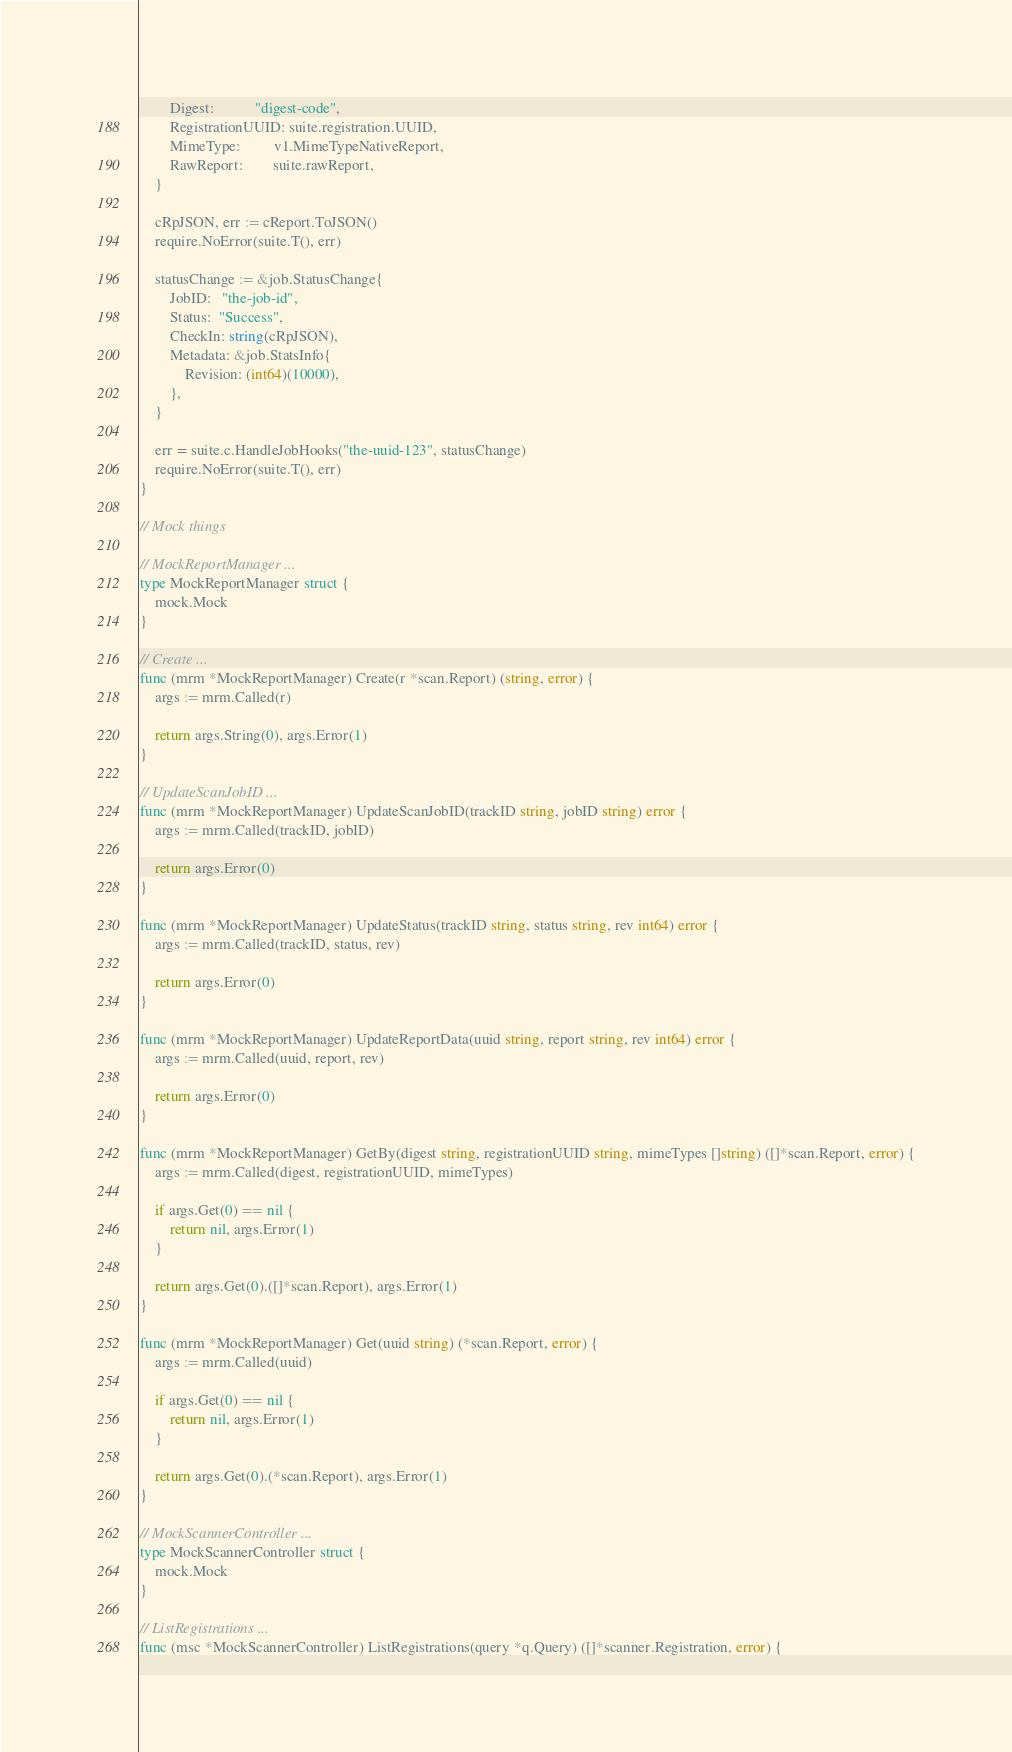Convert code to text. <code><loc_0><loc_0><loc_500><loc_500><_Go_>		Digest:           "digest-code",
		RegistrationUUID: suite.registration.UUID,
		MimeType:         v1.MimeTypeNativeReport,
		RawReport:        suite.rawReport,
	}

	cRpJSON, err := cReport.ToJSON()
	require.NoError(suite.T(), err)

	statusChange := &job.StatusChange{
		JobID:   "the-job-id",
		Status:  "Success",
		CheckIn: string(cRpJSON),
		Metadata: &job.StatsInfo{
			Revision: (int64)(10000),
		},
	}

	err = suite.c.HandleJobHooks("the-uuid-123", statusChange)
	require.NoError(suite.T(), err)
}

// Mock things

// MockReportManager ...
type MockReportManager struct {
	mock.Mock
}

// Create ...
func (mrm *MockReportManager) Create(r *scan.Report) (string, error) {
	args := mrm.Called(r)

	return args.String(0), args.Error(1)
}

// UpdateScanJobID ...
func (mrm *MockReportManager) UpdateScanJobID(trackID string, jobID string) error {
	args := mrm.Called(trackID, jobID)

	return args.Error(0)
}

func (mrm *MockReportManager) UpdateStatus(trackID string, status string, rev int64) error {
	args := mrm.Called(trackID, status, rev)

	return args.Error(0)
}

func (mrm *MockReportManager) UpdateReportData(uuid string, report string, rev int64) error {
	args := mrm.Called(uuid, report, rev)

	return args.Error(0)
}

func (mrm *MockReportManager) GetBy(digest string, registrationUUID string, mimeTypes []string) ([]*scan.Report, error) {
	args := mrm.Called(digest, registrationUUID, mimeTypes)

	if args.Get(0) == nil {
		return nil, args.Error(1)
	}

	return args.Get(0).([]*scan.Report), args.Error(1)
}

func (mrm *MockReportManager) Get(uuid string) (*scan.Report, error) {
	args := mrm.Called(uuid)

	if args.Get(0) == nil {
		return nil, args.Error(1)
	}

	return args.Get(0).(*scan.Report), args.Error(1)
}

// MockScannerController ...
type MockScannerController struct {
	mock.Mock
}

// ListRegistrations ...
func (msc *MockScannerController) ListRegistrations(query *q.Query) ([]*scanner.Registration, error) {</code> 